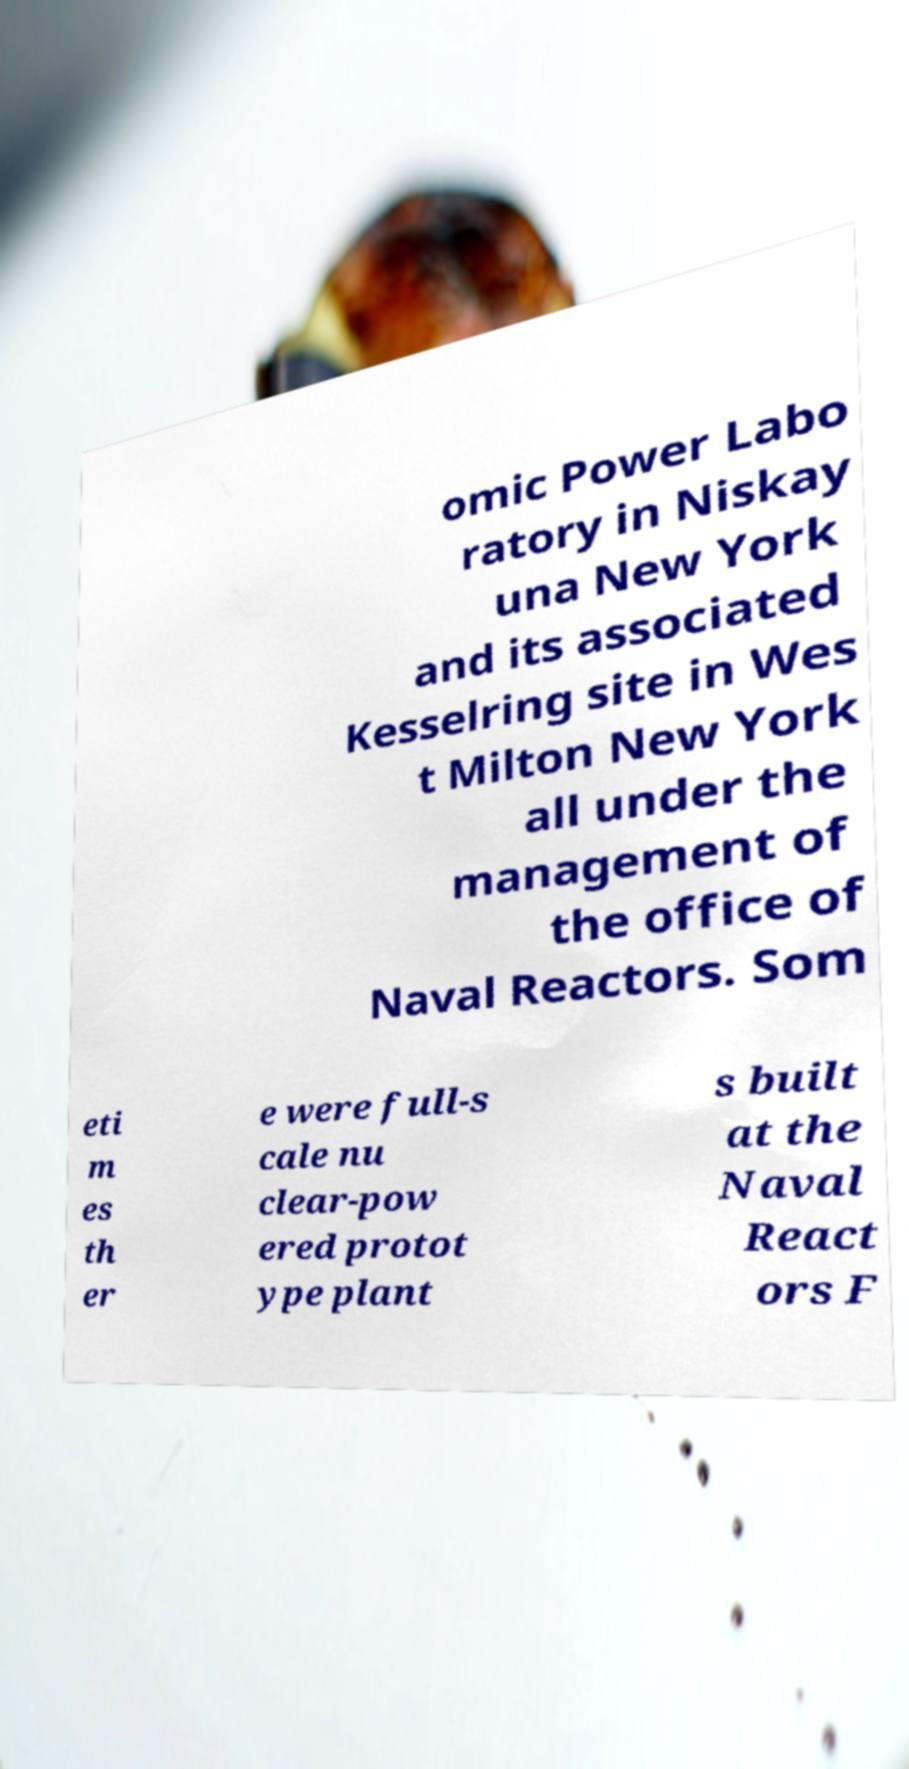I need the written content from this picture converted into text. Can you do that? omic Power Labo ratory in Niskay una New York and its associated Kesselring site in Wes t Milton New York all under the management of the office of Naval Reactors. Som eti m es th er e were full-s cale nu clear-pow ered protot ype plant s built at the Naval React ors F 